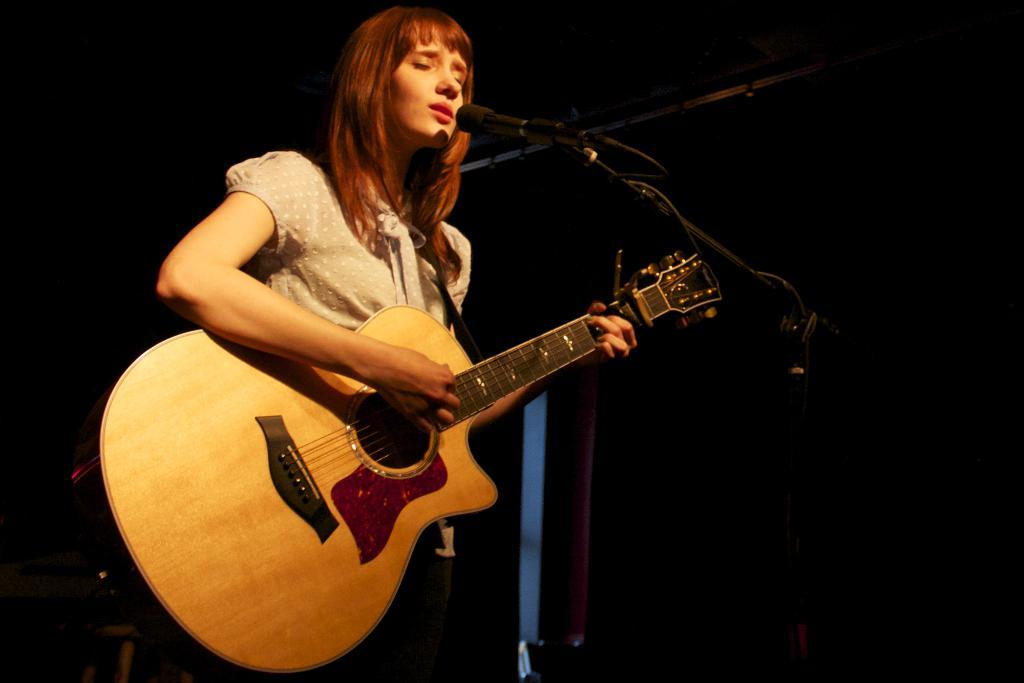Who is the main subject in the image? There is a woman in the image. What is the woman holding in the image? The woman is holding a guitar. What object is in front of the woman? There is a microphone in front of the woman. What type of bells can be heard ringing in the image? There are no bells present in the image, and therefore no sound can be heard. 